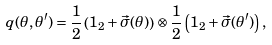<formula> <loc_0><loc_0><loc_500><loc_500>q ( \theta , \theta ^ { \prime } ) = \frac { 1 } { 2 } \left ( 1 _ { 2 } + \vec { \sigma } ( \theta ) \right ) \otimes \frac { 1 } { 2 } \left ( 1 _ { 2 } + \vec { \sigma } ( \theta ^ { \prime } ) \right ) ,</formula> 